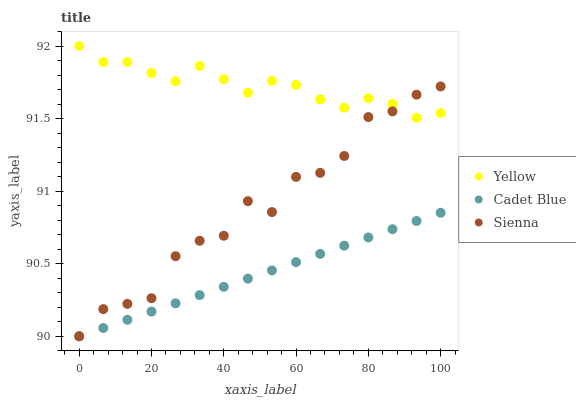Does Cadet Blue have the minimum area under the curve?
Answer yes or no. Yes. Does Yellow have the maximum area under the curve?
Answer yes or no. Yes. Does Yellow have the minimum area under the curve?
Answer yes or no. No. Does Cadet Blue have the maximum area under the curve?
Answer yes or no. No. Is Cadet Blue the smoothest?
Answer yes or no. Yes. Is Sienna the roughest?
Answer yes or no. Yes. Is Yellow the smoothest?
Answer yes or no. No. Is Yellow the roughest?
Answer yes or no. No. Does Sienna have the lowest value?
Answer yes or no. Yes. Does Yellow have the lowest value?
Answer yes or no. No. Does Yellow have the highest value?
Answer yes or no. Yes. Does Cadet Blue have the highest value?
Answer yes or no. No. Is Cadet Blue less than Yellow?
Answer yes or no. Yes. Is Yellow greater than Cadet Blue?
Answer yes or no. Yes. Does Sienna intersect Cadet Blue?
Answer yes or no. Yes. Is Sienna less than Cadet Blue?
Answer yes or no. No. Is Sienna greater than Cadet Blue?
Answer yes or no. No. Does Cadet Blue intersect Yellow?
Answer yes or no. No. 